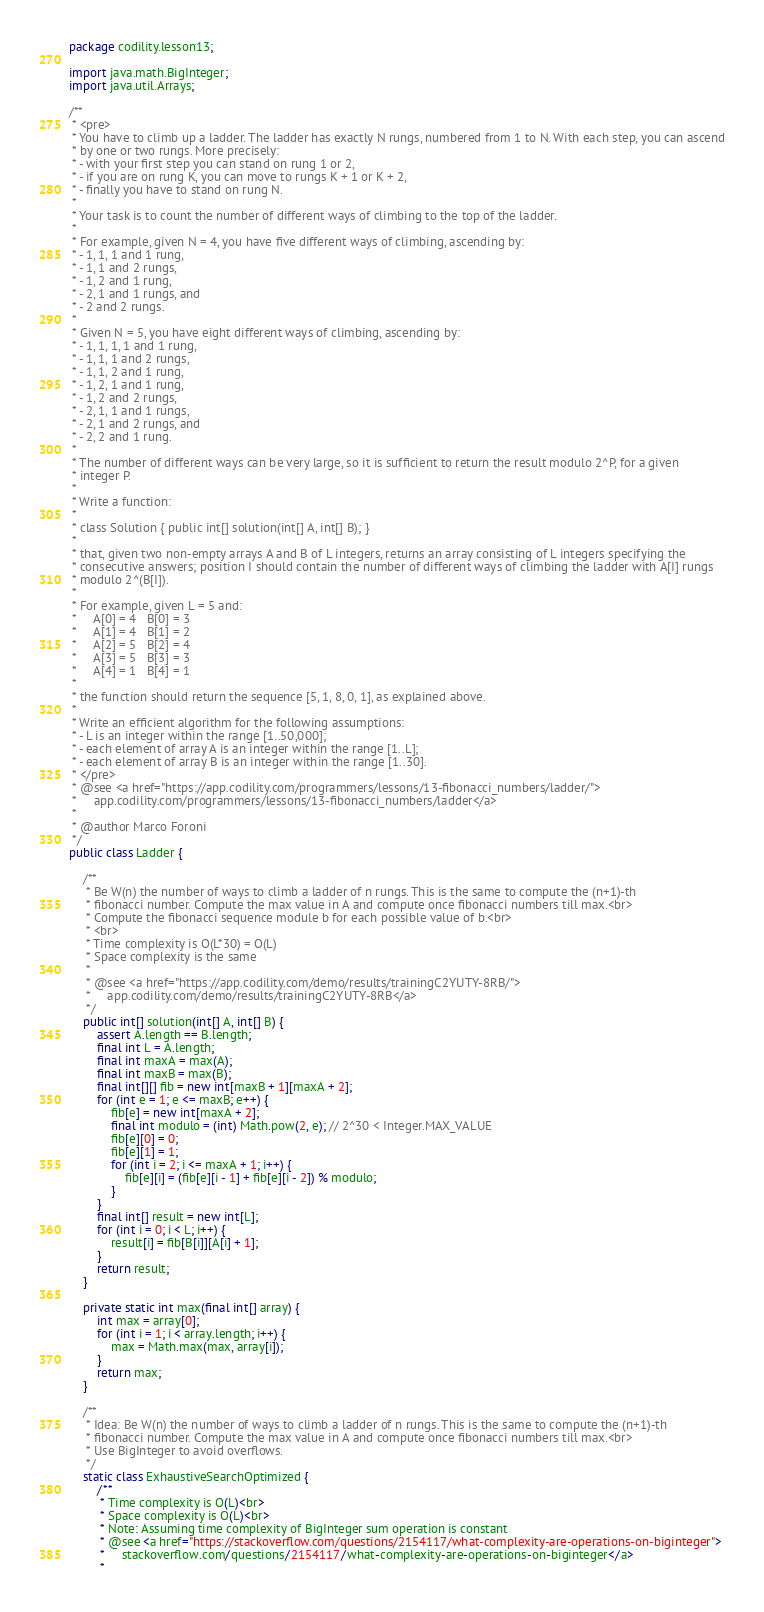<code> <loc_0><loc_0><loc_500><loc_500><_Java_>package codility.lesson13;

import java.math.BigInteger;
import java.util.Arrays;

/**
 * <pre>
 * You have to climb up a ladder. The ladder has exactly N rungs, numbered from 1 to N. With each step, you can ascend
 * by one or two rungs. More precisely:
 * - with your first step you can stand on rung 1 or 2,
 * - if you are on rung K, you can move to rungs K + 1 or K + 2,
 * - finally you have to stand on rung N.
 *
 * Your task is to count the number of different ways of climbing to the top of the ladder.
 *
 * For example, given N = 4, you have five different ways of climbing, ascending by:
 * - 1, 1, 1 and 1 rung,
 * - 1, 1 and 2 rungs,
 * - 1, 2 and 1 rung,
 * - 2, 1 and 1 rungs, and
 * - 2 and 2 rungs.
 *
 * Given N = 5, you have eight different ways of climbing, ascending by:
 * - 1, 1, 1, 1 and 1 rung,
 * - 1, 1, 1 and 2 rungs,
 * - 1, 1, 2 and 1 rung,
 * - 1, 2, 1 and 1 rung,
 * - 1, 2 and 2 rungs,
 * - 2, 1, 1 and 1 rungs,
 * - 2, 1 and 2 rungs, and
 * - 2, 2 and 1 rung.
 *
 * The number of different ways can be very large, so it is sufficient to return the result modulo 2^P, for a given
 * integer P.
 *
 * Write a function:
 *
 * class Solution { public int[] solution(int[] A, int[] B); }
 *
 * that, given two non-empty arrays A and B of L integers, returns an array consisting of L integers specifying the
 * consecutive answers; position I should contain the number of different ways of climbing the ladder with A[I] rungs
 * modulo 2^(B[I]).
 *
 * For example, given L = 5 and:
 *     A[0] = 4   B[0] = 3
 *     A[1] = 4   B[1] = 2
 *     A[2] = 5   B[2] = 4
 *     A[3] = 5   B[3] = 3
 *     A[4] = 1   B[4] = 1
 *
 * the function should return the sequence [5, 1, 8, 0, 1], as explained above.
 *
 * Write an efficient algorithm for the following assumptions:
 * - L is an integer within the range [1..50,000];
 * - each element of array A is an integer within the range [1..L];
 * - each element of array B is an integer within the range [1..30].
 * </pre>
 * @see <a href="https://app.codility.com/programmers/lessons/13-fibonacci_numbers/ladder/">
 *     app.codility.com/programmers/lessons/13-fibonacci_numbers/ladder</a>
 *
 * @author Marco Foroni
 */
public class Ladder {

    /**
     * Be W(n) the number of ways to climb a ladder of n rungs. This is the same to compute the (n+1)-th
     * fibonacci number. Compute the max value in A and compute once fibonacci numbers till max.<br>
     * Compute the fibonacci sequence module b for each possible value of b.<br>
     * <br>
     * Time complexity is O(L*30) = O(L)
     * Space complexity is the same
     *
     * @see <a href="https://app.codility.com/demo/results/trainingC2YUTY-8RB/">
     *     app.codility.com/demo/results/trainingC2YUTY-8RB</a>
     */
    public int[] solution(int[] A, int[] B) {
        assert A.length == B.length;
        final int L = A.length;
        final int maxA = max(A);
        final int maxB = max(B);
        final int[][] fib = new int[maxB + 1][maxA + 2];
        for (int e = 1; e <= maxB; e++) {
            fib[e] = new int[maxA + 2];
            final int modulo = (int) Math.pow(2, e); // 2^30 < Integer.MAX_VALUE
            fib[e][0] = 0;
            fib[e][1] = 1;
            for (int i = 2; i <= maxA + 1; i++) {
                fib[e][i] = (fib[e][i - 1] + fib[e][i - 2]) % modulo;
            }
        }
        final int[] result = new int[L];
        for (int i = 0; i < L; i++) {
            result[i] = fib[B[i]][A[i] + 1];
        }
        return result;
    }

    private static int max(final int[] array) {
        int max = array[0];
        for (int i = 1; i < array.length; i++) {
            max = Math.max(max, array[i]);
        }
        return max;
    }

    /**
     * Idea: Be W(n) the number of ways to climb a ladder of n rungs. This is the same to compute the (n+1)-th
     * fibonacci number. Compute the max value in A and compute once fibonacci numbers till max.<br>
     * Use BigInteger to avoid overflows.
     */
    static class ExhaustiveSearchOptimized {
        /**
         * Time complexity is O(L)<br>
         * Space complexity is O(L)<br>
         * Note: Assuming time complexity of BigInteger sum operation is constant
         * @see <a href="https://stackoverflow.com/questions/2154117/what-complexity-are-operations-on-biginteger">
         *     stackoverflow.com/questions/2154117/what-complexity-are-operations-on-biginteger</a>
         *</code> 